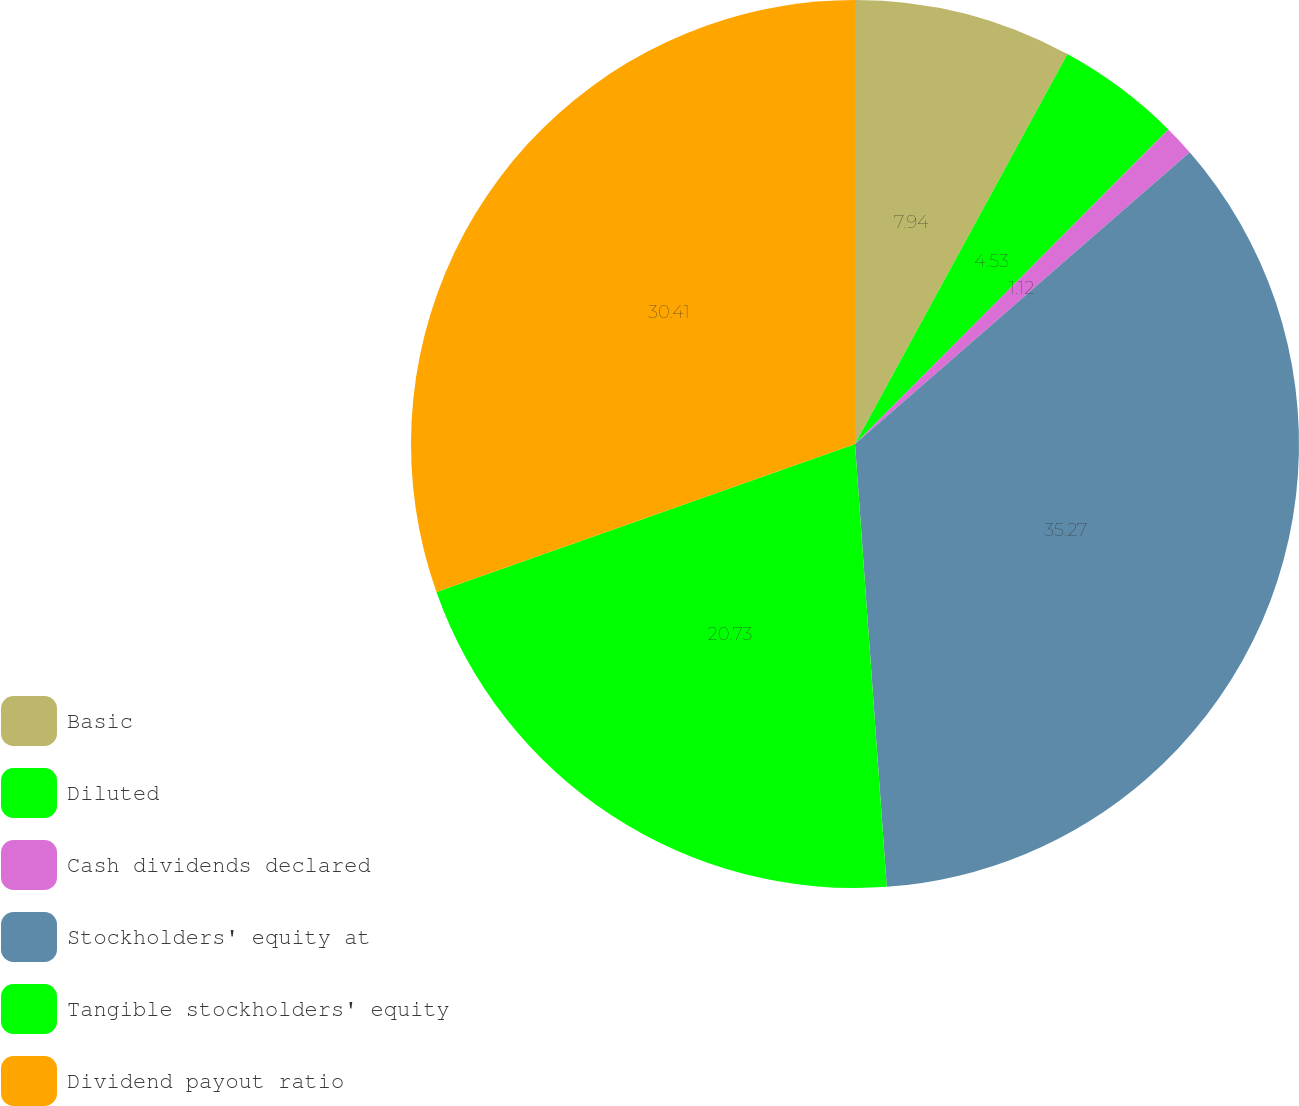Convert chart. <chart><loc_0><loc_0><loc_500><loc_500><pie_chart><fcel>Basic<fcel>Diluted<fcel>Cash dividends declared<fcel>Stockholders' equity at<fcel>Tangible stockholders' equity<fcel>Dividend payout ratio<nl><fcel>7.94%<fcel>4.53%<fcel>1.12%<fcel>35.27%<fcel>20.73%<fcel>30.41%<nl></chart> 